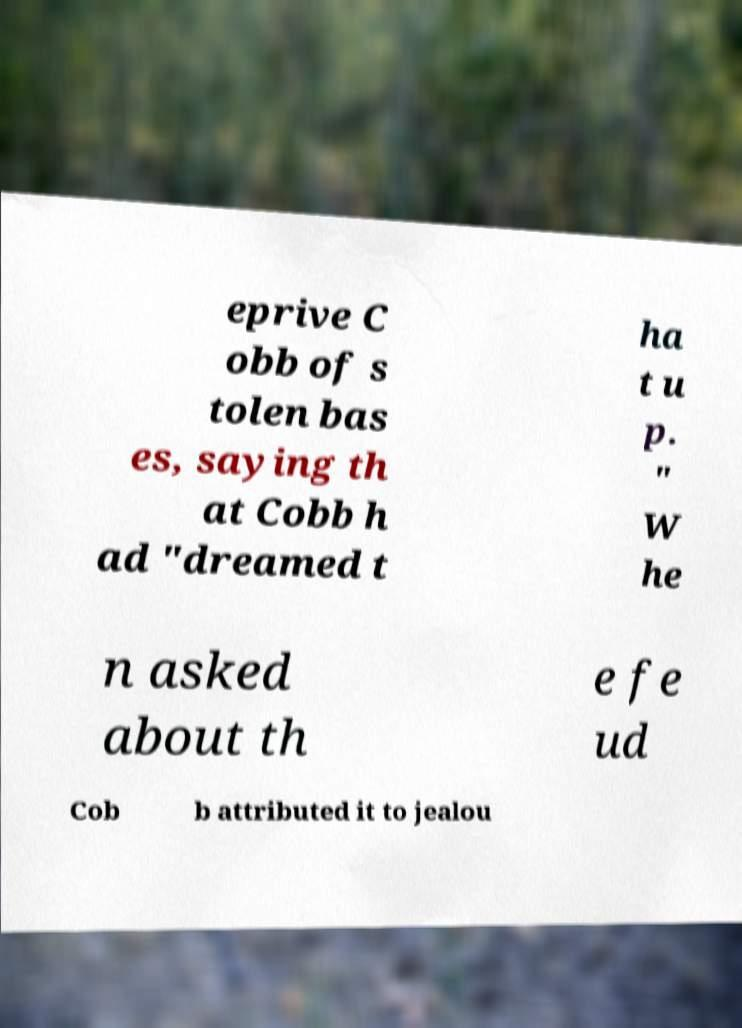Can you read and provide the text displayed in the image?This photo seems to have some interesting text. Can you extract and type it out for me? eprive C obb of s tolen bas es, saying th at Cobb h ad "dreamed t ha t u p. " W he n asked about th e fe ud Cob b attributed it to jealou 